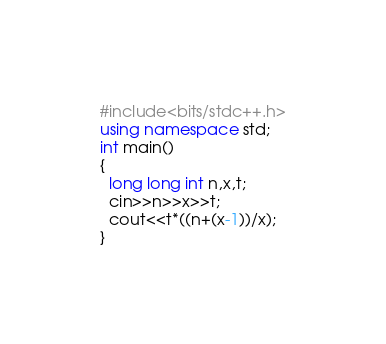Convert code to text. <code><loc_0><loc_0><loc_500><loc_500><_C++_>#include<bits/stdc++.h>
using namespace std;
int main()
{
  long long int n,x,t;
  cin>>n>>x>>t;
  cout<<t*((n+(x-1))/x);
}
</code> 